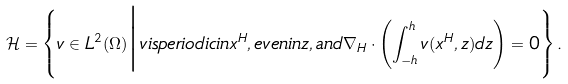Convert formula to latex. <formula><loc_0><loc_0><loc_500><loc_500>\mathcal { H } = \left \{ v \in L ^ { 2 } ( \Omega ) \Big | v i s p e r i o d i c i n x ^ { H } , e v e n i n z , a n d \nabla _ { H } \cdot \left ( \int _ { - h } ^ { h } v ( x ^ { H } , z ) d z \right ) = 0 \right \} .</formula> 